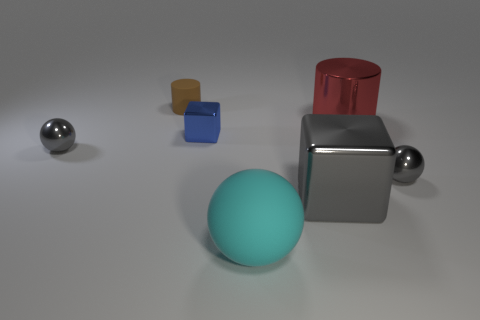Add 2 big blue blocks. How many objects exist? 9 Subtract all balls. How many objects are left? 4 Subtract all tiny blue metal things. Subtract all gray metal objects. How many objects are left? 3 Add 4 blue objects. How many blue objects are left? 5 Add 2 small blue metallic cubes. How many small blue metallic cubes exist? 3 Subtract 1 blue blocks. How many objects are left? 6 